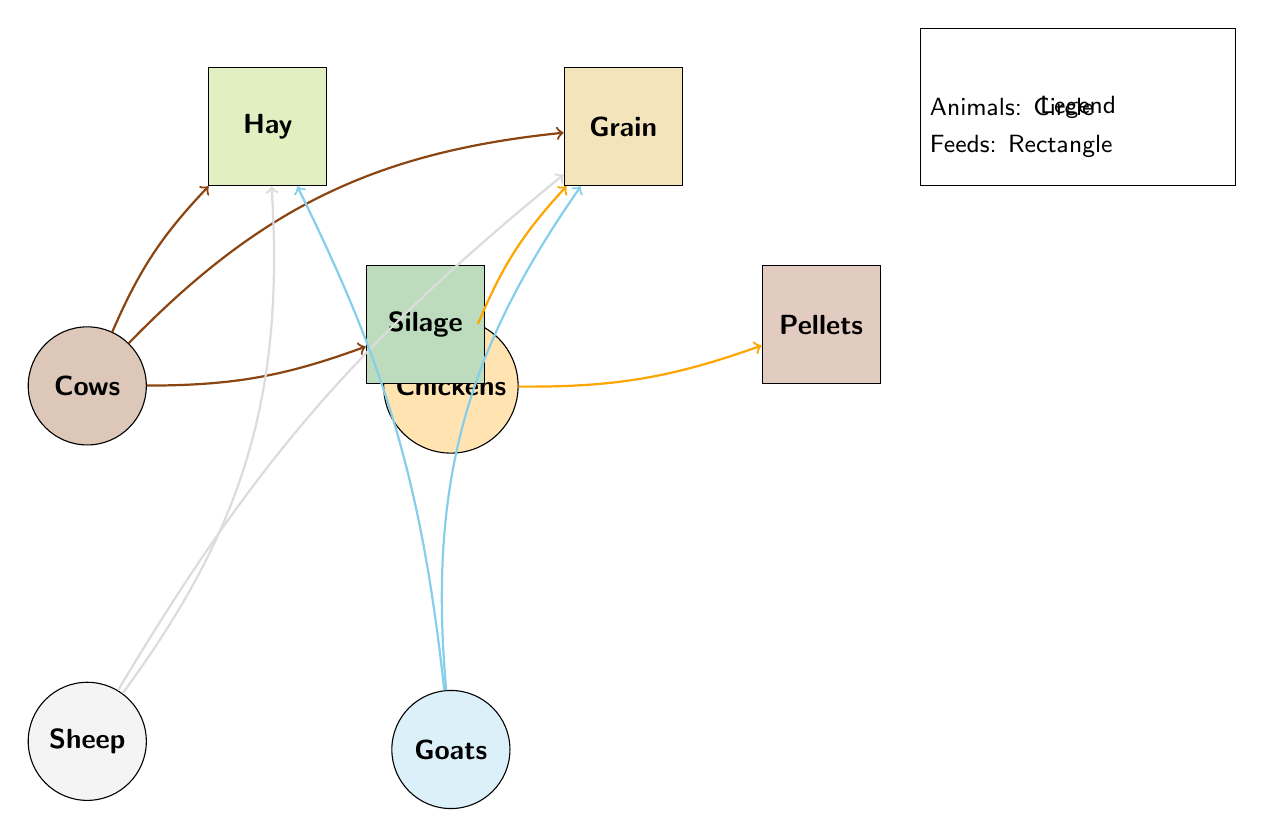What feeds do Cows eat? The diagram shows connections from the Cows node to the Hay, Grain, and Silage feed types, indicating that these are the feeds provided for Cows.
Answer: Hay, Grain, Silage How many types of feed are there? By looking at the diagram, I see four feed types: Hay, Grain, Pellets, and Silage, which means there are a total of four types of feed represented.
Answer: 4 Which animal eats Pellets? There is a direct connection drawn from the Chickens node to the Pellets feed type, indicating that Chickens are the only animals eating Pellets in this diagram.
Answer: Chickens What is the relationship between Sheep and Hay? The diagram shows a link from Sheep to Hay, indicating that Sheep are fed Hay. This connection depicts a feeding relationship.
Answer: Sheep are fed Hay How many animals eat Grain? Observing the diagram, I see that both Cows, Chickens, Sheep, and Goats have connections to Grain, summing up to four animals that eat Grain.
Answer: 4 Which feed type is the only one linked to Goats? Upon examining the diagram, Goats are connected to Hay and Grain, leaving no unique feed type exclusively linked to them other than the feeds they share with other animals.
Answer: Hay, Grain Which two animals both eat Hay? By analyzing the connections from Hay, I can see that both Cows and Sheep are linked to Hay, which means these two animals consume Hay.
Answer: Cows, Sheep What is the total number of connections in the diagram? By tallying the links shown in the diagram between the animals and the feed types, I find there are a total of eight connections displayed.
Answer: 8 